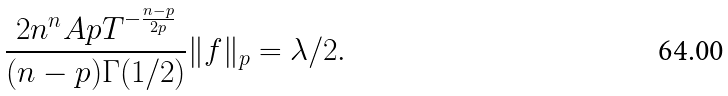<formula> <loc_0><loc_0><loc_500><loc_500>\frac { 2 n ^ { n } A p T ^ { - \frac { n - p } { 2 p } } } { ( n - p ) \Gamma ( 1 / 2 ) } \| f \| _ { p } = \lambda / 2 .</formula> 